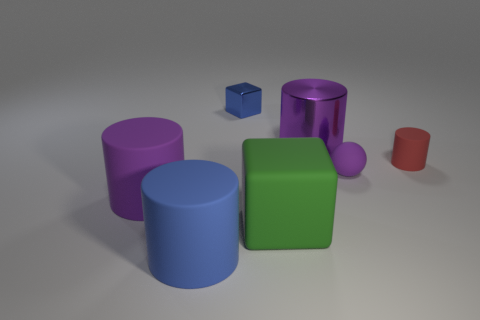Subtract all small rubber cylinders. How many cylinders are left? 3 Subtract all red cylinders. How many cylinders are left? 3 Add 2 small green shiny things. How many objects exist? 9 Subtract 2 cylinders. How many cylinders are left? 2 Subtract all gray balls. Subtract all green cylinders. How many balls are left? 1 Subtract all balls. How many objects are left? 6 Subtract all red blocks. How many gray spheres are left? 0 Add 2 blue matte cylinders. How many blue matte cylinders are left? 3 Add 5 big matte objects. How many big matte objects exist? 8 Subtract 0 gray spheres. How many objects are left? 7 